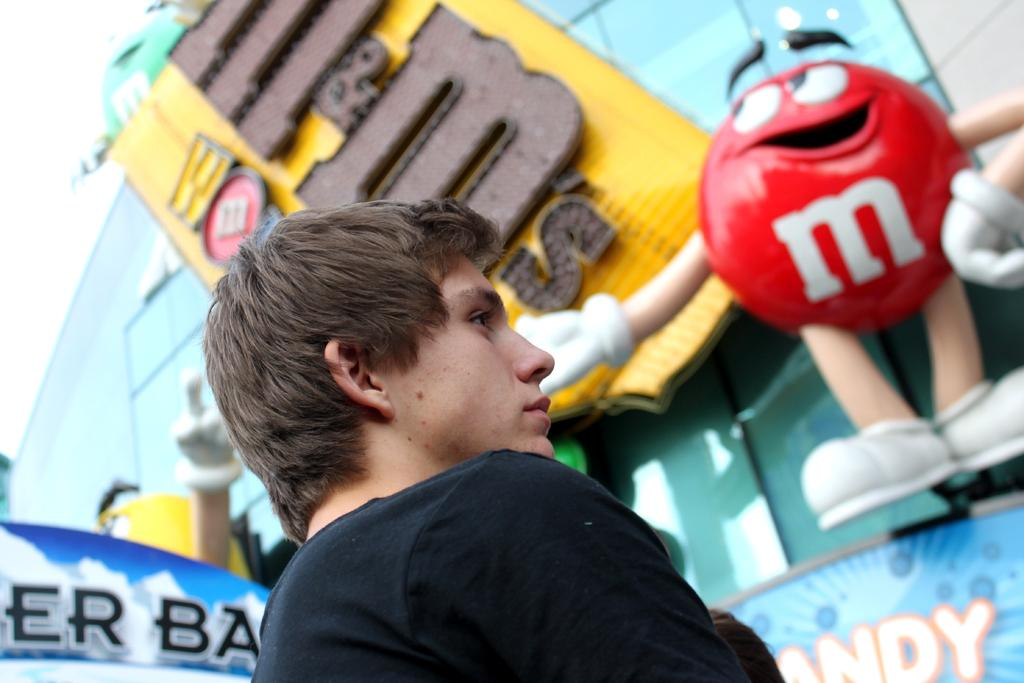Who is present in the image? There is a person in the image. What is the person wearing? The person is wearing a black dress. What can be seen in the background of the image? There is a colorful board visible in the background. What type of toy is present in the image? There is a red color toy in the image. How many flowers are on the person's hands in the image? There are no flowers present on the person's hands in the image. What type of can is visible in the image? There is no can present in the image. 